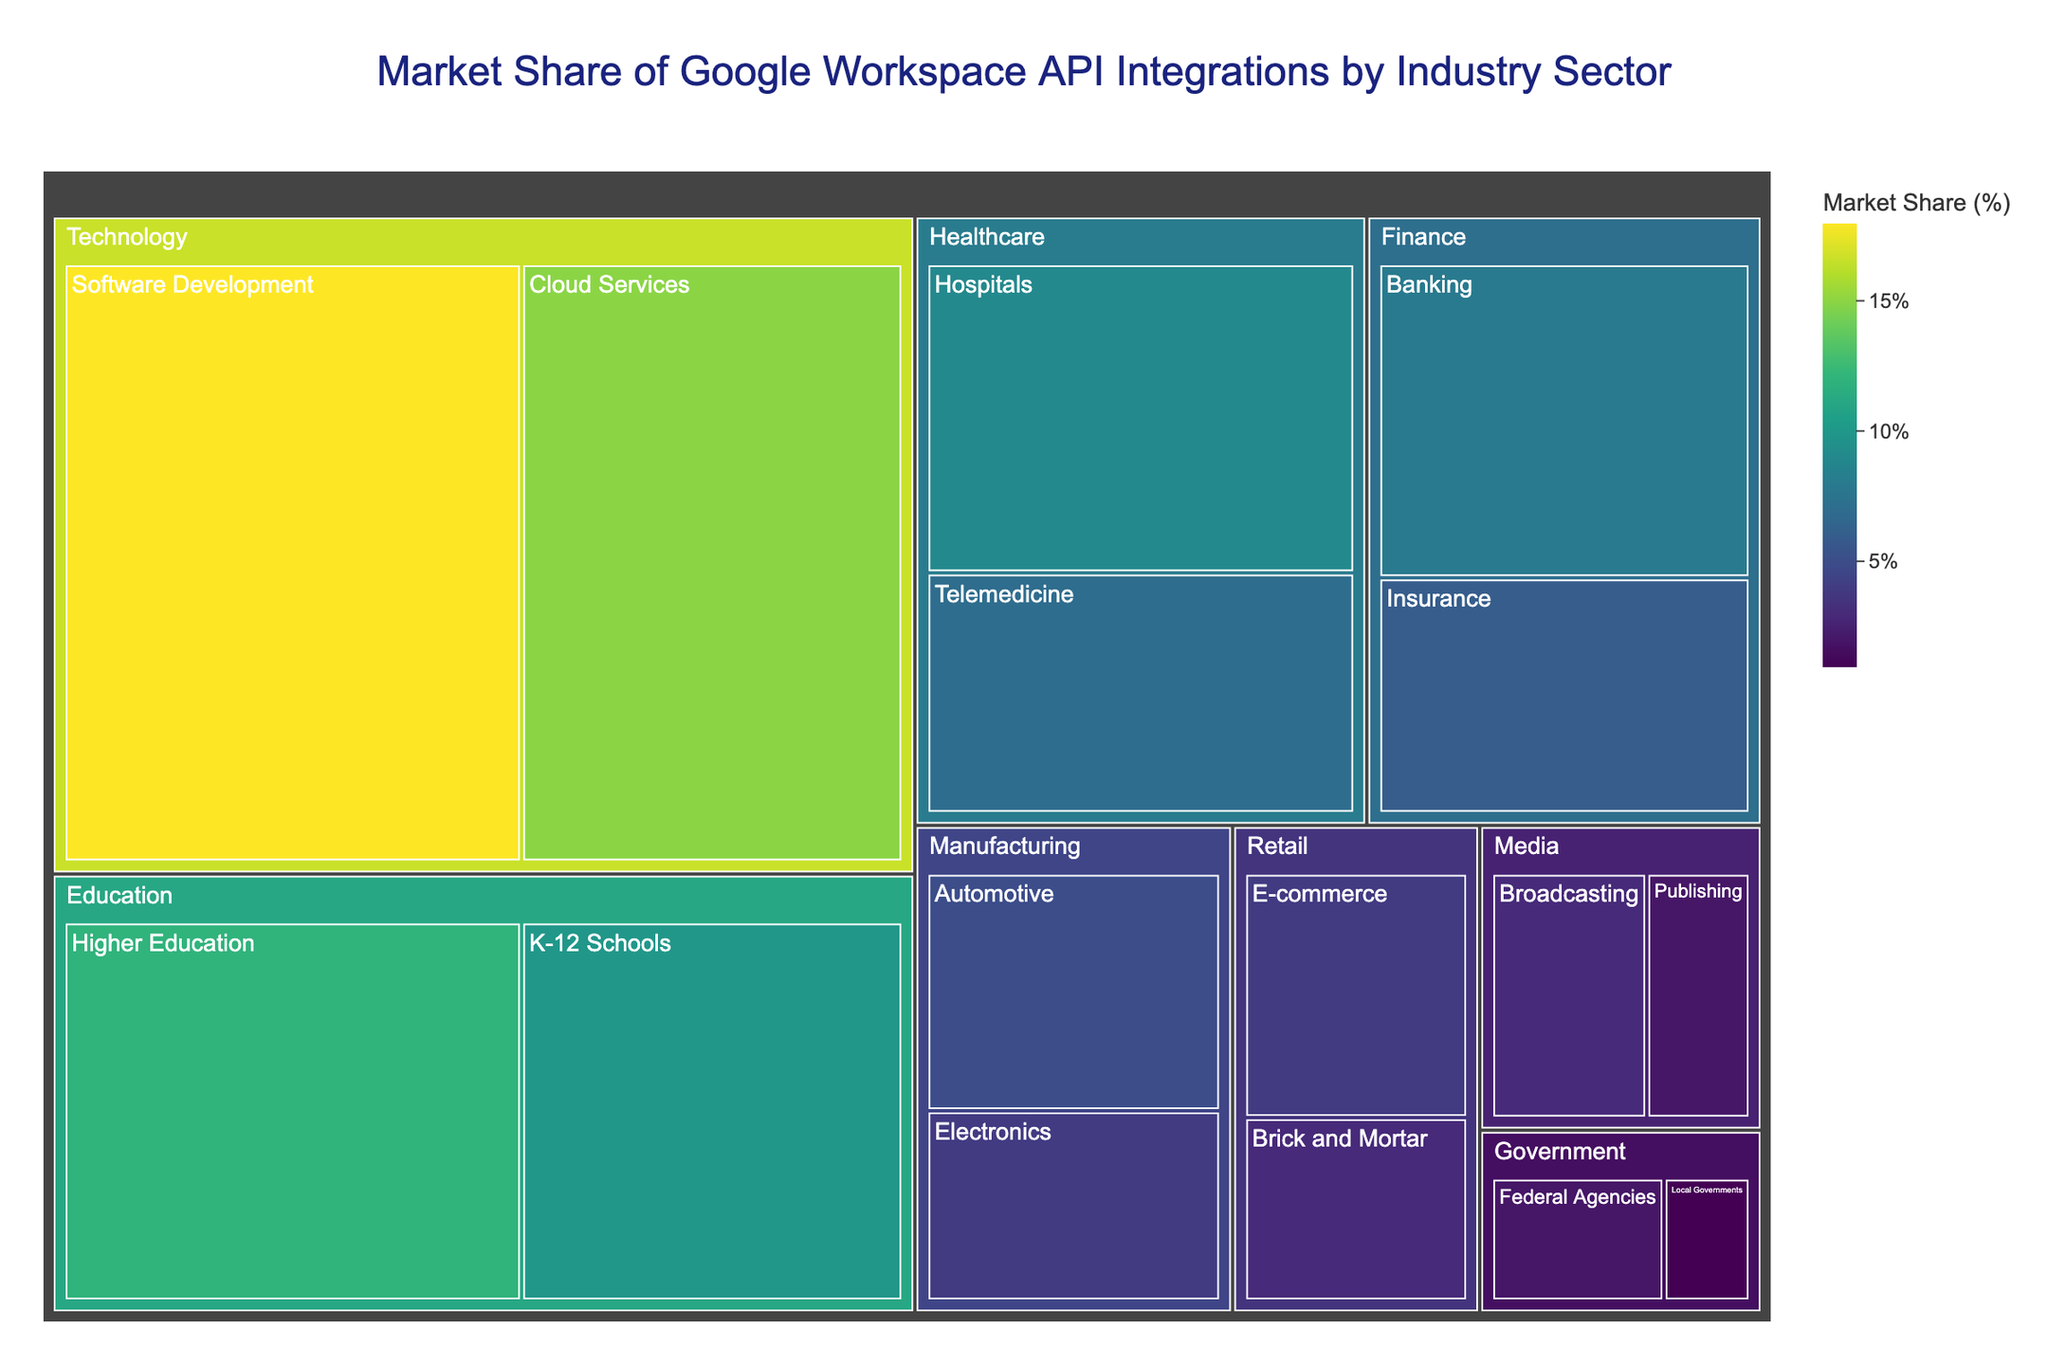What's the title of the treemap? The title of the treemap is displayed at the top center of the figure. The title provides an overview of what the figure represents.
Answer: Market Share of Google Workspace API Integrations by Industry Sector Which industry has the largest market share? The largest section of the treemap belongs to the technology industry, indicating that it has the largest market share among all the industries listed.
Answer: Technology What's the combined market share of the Healthcare sector? The Healthcare sector combines the Hospitals and Telemedicine shares. Adding these together gives 9% + 7% = 16%.
Answer: 16% Which sector in the Finance industry has a higher market share? In the Finance industry, the Banking sector has an 8% share and the Insurance sector has a 6% share. Comparing the two, Banking has a higher market share.
Answer: Banking What industry has the smallest market share? The smallest section within the treemap belongs to the Government industry with a combined share of 3% (Federal Agencies 2% + Local Governments 1%).
Answer: Government What's the difference in market share between Software Development and Cloud Services? Software Development has a market share of 18%, whereas Cloud Services has a market share of 15%. The difference is 18% - 15% = 3%.
Answer: 3% How many industry sectors have a market share less than 5%? From visual inspection, sectors with less than 5% share include Electronics, E-commerce, Brick and Mortar, Broadcasting, Publishing, Federal Agencies, and Local Governments. There are a total of 7 such sectors.
Answer: 7 What is the market share of K-12 Schools within the Education industry? The K-12 Schools sector has a market share of 10%, which is part of the Education industry.
Answer: 10% Which sector within the Manufacturing industry has a larger market share? The Automotive sector has a market share of 5%, while the Electronics sector has a share of 4%. Therefore, the Automotive sector has a larger market share in the Manufacturing industry.
Answer: Automotive What's the total market share of Retail and Media industries combined? The Retail industry combines E-commerce (4%) and Brick and Mortar (3%), summing to 7%. The Media industry combines Broadcasting (3%) and Publishing (2%), summing to 5%. Thus, Retail and Media together have 7% + 5% = 12%.
Answer: 12% 